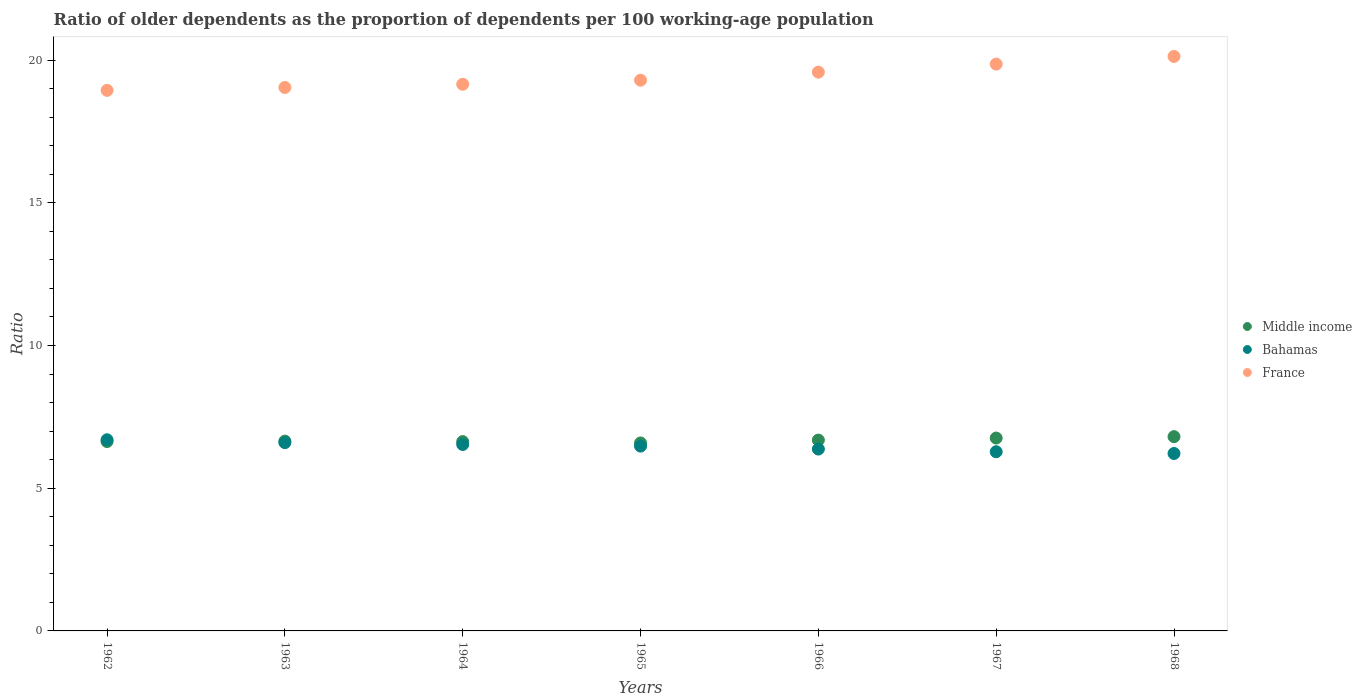What is the age dependency ratio(old) in France in 1967?
Provide a succinct answer. 19.86. Across all years, what is the maximum age dependency ratio(old) in France?
Offer a terse response. 20.13. Across all years, what is the minimum age dependency ratio(old) in France?
Provide a succinct answer. 18.94. In which year was the age dependency ratio(old) in Middle income maximum?
Ensure brevity in your answer.  1968. In which year was the age dependency ratio(old) in Bahamas minimum?
Your response must be concise. 1968. What is the total age dependency ratio(old) in Middle income in the graph?
Offer a terse response. 46.76. What is the difference between the age dependency ratio(old) in Bahamas in 1964 and that in 1966?
Provide a short and direct response. 0.16. What is the difference between the age dependency ratio(old) in Bahamas in 1966 and the age dependency ratio(old) in France in 1968?
Your response must be concise. -13.76. What is the average age dependency ratio(old) in Middle income per year?
Offer a very short reply. 6.68. In the year 1966, what is the difference between the age dependency ratio(old) in France and age dependency ratio(old) in Middle income?
Keep it short and to the point. 12.89. What is the ratio of the age dependency ratio(old) in Bahamas in 1964 to that in 1967?
Keep it short and to the point. 1.04. Is the age dependency ratio(old) in Middle income in 1962 less than that in 1963?
Provide a short and direct response. Yes. What is the difference between the highest and the second highest age dependency ratio(old) in Bahamas?
Your answer should be very brief. 0.1. What is the difference between the highest and the lowest age dependency ratio(old) in France?
Your answer should be very brief. 1.19. Does the age dependency ratio(old) in Middle income monotonically increase over the years?
Ensure brevity in your answer.  No. Is the age dependency ratio(old) in Bahamas strictly greater than the age dependency ratio(old) in France over the years?
Your answer should be compact. No. What is the difference between two consecutive major ticks on the Y-axis?
Your answer should be compact. 5. Does the graph contain any zero values?
Your answer should be compact. No. Does the graph contain grids?
Provide a succinct answer. No. How many legend labels are there?
Offer a terse response. 3. How are the legend labels stacked?
Ensure brevity in your answer.  Vertical. What is the title of the graph?
Provide a short and direct response. Ratio of older dependents as the proportion of dependents per 100 working-age population. What is the label or title of the Y-axis?
Your answer should be very brief. Ratio. What is the Ratio in Middle income in 1962?
Keep it short and to the point. 6.64. What is the Ratio in Bahamas in 1962?
Your answer should be very brief. 6.7. What is the Ratio in France in 1962?
Your answer should be compact. 18.94. What is the Ratio in Middle income in 1963?
Your answer should be very brief. 6.65. What is the Ratio of Bahamas in 1963?
Ensure brevity in your answer.  6.6. What is the Ratio of France in 1963?
Offer a very short reply. 19.04. What is the Ratio in Middle income in 1964?
Your answer should be compact. 6.63. What is the Ratio in Bahamas in 1964?
Offer a very short reply. 6.53. What is the Ratio in France in 1964?
Provide a short and direct response. 19.15. What is the Ratio of Middle income in 1965?
Offer a terse response. 6.59. What is the Ratio in Bahamas in 1965?
Your response must be concise. 6.48. What is the Ratio of France in 1965?
Your answer should be very brief. 19.3. What is the Ratio in Middle income in 1966?
Provide a succinct answer. 6.69. What is the Ratio of Bahamas in 1966?
Offer a terse response. 6.37. What is the Ratio of France in 1966?
Make the answer very short. 19.58. What is the Ratio of Middle income in 1967?
Offer a very short reply. 6.76. What is the Ratio of Bahamas in 1967?
Your answer should be compact. 6.28. What is the Ratio of France in 1967?
Your answer should be compact. 19.86. What is the Ratio in Middle income in 1968?
Your response must be concise. 6.81. What is the Ratio in Bahamas in 1968?
Your response must be concise. 6.22. What is the Ratio of France in 1968?
Provide a succinct answer. 20.13. Across all years, what is the maximum Ratio in Middle income?
Make the answer very short. 6.81. Across all years, what is the maximum Ratio of Bahamas?
Provide a short and direct response. 6.7. Across all years, what is the maximum Ratio in France?
Ensure brevity in your answer.  20.13. Across all years, what is the minimum Ratio in Middle income?
Ensure brevity in your answer.  6.59. Across all years, what is the minimum Ratio of Bahamas?
Provide a succinct answer. 6.22. Across all years, what is the minimum Ratio of France?
Give a very brief answer. 18.94. What is the total Ratio in Middle income in the graph?
Give a very brief answer. 46.76. What is the total Ratio of Bahamas in the graph?
Make the answer very short. 45.17. What is the total Ratio of France in the graph?
Offer a terse response. 136. What is the difference between the Ratio in Middle income in 1962 and that in 1963?
Make the answer very short. -0.02. What is the difference between the Ratio in Bahamas in 1962 and that in 1963?
Offer a very short reply. 0.1. What is the difference between the Ratio in France in 1962 and that in 1963?
Make the answer very short. -0.1. What is the difference between the Ratio in Middle income in 1962 and that in 1964?
Give a very brief answer. 0. What is the difference between the Ratio of Bahamas in 1962 and that in 1964?
Provide a short and direct response. 0.16. What is the difference between the Ratio of France in 1962 and that in 1964?
Keep it short and to the point. -0.21. What is the difference between the Ratio in Middle income in 1962 and that in 1965?
Keep it short and to the point. 0.05. What is the difference between the Ratio in Bahamas in 1962 and that in 1965?
Offer a terse response. 0.22. What is the difference between the Ratio in France in 1962 and that in 1965?
Your answer should be very brief. -0.36. What is the difference between the Ratio in Middle income in 1962 and that in 1966?
Give a very brief answer. -0.05. What is the difference between the Ratio of Bahamas in 1962 and that in 1966?
Provide a short and direct response. 0.33. What is the difference between the Ratio of France in 1962 and that in 1966?
Your response must be concise. -0.64. What is the difference between the Ratio of Middle income in 1962 and that in 1967?
Make the answer very short. -0.12. What is the difference between the Ratio in Bahamas in 1962 and that in 1967?
Make the answer very short. 0.42. What is the difference between the Ratio of France in 1962 and that in 1967?
Keep it short and to the point. -0.92. What is the difference between the Ratio of Middle income in 1962 and that in 1968?
Make the answer very short. -0.17. What is the difference between the Ratio in Bahamas in 1962 and that in 1968?
Your answer should be very brief. 0.48. What is the difference between the Ratio of France in 1962 and that in 1968?
Keep it short and to the point. -1.19. What is the difference between the Ratio in Middle income in 1963 and that in 1964?
Ensure brevity in your answer.  0.02. What is the difference between the Ratio in Bahamas in 1963 and that in 1964?
Provide a succinct answer. 0.07. What is the difference between the Ratio in France in 1963 and that in 1964?
Provide a succinct answer. -0.11. What is the difference between the Ratio of Middle income in 1963 and that in 1965?
Keep it short and to the point. 0.07. What is the difference between the Ratio of Bahamas in 1963 and that in 1965?
Keep it short and to the point. 0.12. What is the difference between the Ratio in France in 1963 and that in 1965?
Your answer should be very brief. -0.25. What is the difference between the Ratio of Middle income in 1963 and that in 1966?
Ensure brevity in your answer.  -0.04. What is the difference between the Ratio of Bahamas in 1963 and that in 1966?
Provide a succinct answer. 0.23. What is the difference between the Ratio in France in 1963 and that in 1966?
Give a very brief answer. -0.54. What is the difference between the Ratio in Middle income in 1963 and that in 1967?
Make the answer very short. -0.11. What is the difference between the Ratio in Bahamas in 1963 and that in 1967?
Your response must be concise. 0.32. What is the difference between the Ratio in France in 1963 and that in 1967?
Provide a short and direct response. -0.82. What is the difference between the Ratio of Middle income in 1963 and that in 1968?
Offer a very short reply. -0.16. What is the difference between the Ratio of Bahamas in 1963 and that in 1968?
Make the answer very short. 0.38. What is the difference between the Ratio of France in 1963 and that in 1968?
Offer a terse response. -1.09. What is the difference between the Ratio of Middle income in 1964 and that in 1965?
Provide a succinct answer. 0.05. What is the difference between the Ratio in Bahamas in 1964 and that in 1965?
Ensure brevity in your answer.  0.06. What is the difference between the Ratio in France in 1964 and that in 1965?
Give a very brief answer. -0.14. What is the difference between the Ratio in Middle income in 1964 and that in 1966?
Ensure brevity in your answer.  -0.05. What is the difference between the Ratio in Bahamas in 1964 and that in 1966?
Ensure brevity in your answer.  0.16. What is the difference between the Ratio in France in 1964 and that in 1966?
Give a very brief answer. -0.43. What is the difference between the Ratio of Middle income in 1964 and that in 1967?
Ensure brevity in your answer.  -0.12. What is the difference between the Ratio of Bahamas in 1964 and that in 1967?
Offer a terse response. 0.25. What is the difference between the Ratio in France in 1964 and that in 1967?
Your response must be concise. -0.71. What is the difference between the Ratio in Middle income in 1964 and that in 1968?
Keep it short and to the point. -0.17. What is the difference between the Ratio of Bahamas in 1964 and that in 1968?
Your response must be concise. 0.32. What is the difference between the Ratio of France in 1964 and that in 1968?
Ensure brevity in your answer.  -0.98. What is the difference between the Ratio in Middle income in 1965 and that in 1966?
Ensure brevity in your answer.  -0.1. What is the difference between the Ratio in Bahamas in 1965 and that in 1966?
Provide a short and direct response. 0.1. What is the difference between the Ratio in France in 1965 and that in 1966?
Make the answer very short. -0.28. What is the difference between the Ratio in Middle income in 1965 and that in 1967?
Your answer should be very brief. -0.17. What is the difference between the Ratio of Bahamas in 1965 and that in 1967?
Provide a short and direct response. 0.2. What is the difference between the Ratio in France in 1965 and that in 1967?
Make the answer very short. -0.56. What is the difference between the Ratio in Middle income in 1965 and that in 1968?
Give a very brief answer. -0.22. What is the difference between the Ratio in Bahamas in 1965 and that in 1968?
Keep it short and to the point. 0.26. What is the difference between the Ratio of France in 1965 and that in 1968?
Your response must be concise. -0.83. What is the difference between the Ratio of Middle income in 1966 and that in 1967?
Your answer should be very brief. -0.07. What is the difference between the Ratio in Bahamas in 1966 and that in 1967?
Your answer should be compact. 0.09. What is the difference between the Ratio of France in 1966 and that in 1967?
Make the answer very short. -0.28. What is the difference between the Ratio in Middle income in 1966 and that in 1968?
Provide a short and direct response. -0.12. What is the difference between the Ratio of Bahamas in 1966 and that in 1968?
Provide a succinct answer. 0.15. What is the difference between the Ratio of France in 1966 and that in 1968?
Give a very brief answer. -0.55. What is the difference between the Ratio of Middle income in 1967 and that in 1968?
Make the answer very short. -0.05. What is the difference between the Ratio of Bahamas in 1967 and that in 1968?
Offer a terse response. 0.06. What is the difference between the Ratio of France in 1967 and that in 1968?
Your response must be concise. -0.27. What is the difference between the Ratio of Middle income in 1962 and the Ratio of Bahamas in 1963?
Make the answer very short. 0.04. What is the difference between the Ratio of Middle income in 1962 and the Ratio of France in 1963?
Provide a succinct answer. -12.41. What is the difference between the Ratio of Bahamas in 1962 and the Ratio of France in 1963?
Ensure brevity in your answer.  -12.34. What is the difference between the Ratio of Middle income in 1962 and the Ratio of Bahamas in 1964?
Your response must be concise. 0.1. What is the difference between the Ratio in Middle income in 1962 and the Ratio in France in 1964?
Provide a succinct answer. -12.52. What is the difference between the Ratio in Bahamas in 1962 and the Ratio in France in 1964?
Give a very brief answer. -12.46. What is the difference between the Ratio in Middle income in 1962 and the Ratio in Bahamas in 1965?
Give a very brief answer. 0.16. What is the difference between the Ratio of Middle income in 1962 and the Ratio of France in 1965?
Make the answer very short. -12.66. What is the difference between the Ratio in Bahamas in 1962 and the Ratio in France in 1965?
Give a very brief answer. -12.6. What is the difference between the Ratio in Middle income in 1962 and the Ratio in Bahamas in 1966?
Keep it short and to the point. 0.26. What is the difference between the Ratio in Middle income in 1962 and the Ratio in France in 1966?
Your answer should be very brief. -12.94. What is the difference between the Ratio in Bahamas in 1962 and the Ratio in France in 1966?
Make the answer very short. -12.88. What is the difference between the Ratio of Middle income in 1962 and the Ratio of Bahamas in 1967?
Give a very brief answer. 0.36. What is the difference between the Ratio of Middle income in 1962 and the Ratio of France in 1967?
Make the answer very short. -13.22. What is the difference between the Ratio of Bahamas in 1962 and the Ratio of France in 1967?
Keep it short and to the point. -13.16. What is the difference between the Ratio of Middle income in 1962 and the Ratio of Bahamas in 1968?
Ensure brevity in your answer.  0.42. What is the difference between the Ratio of Middle income in 1962 and the Ratio of France in 1968?
Provide a succinct answer. -13.49. What is the difference between the Ratio of Bahamas in 1962 and the Ratio of France in 1968?
Offer a terse response. -13.43. What is the difference between the Ratio of Middle income in 1963 and the Ratio of Bahamas in 1964?
Provide a short and direct response. 0.12. What is the difference between the Ratio in Middle income in 1963 and the Ratio in France in 1964?
Your answer should be compact. -12.5. What is the difference between the Ratio in Bahamas in 1963 and the Ratio in France in 1964?
Your answer should be very brief. -12.56. What is the difference between the Ratio of Middle income in 1963 and the Ratio of Bahamas in 1965?
Your answer should be very brief. 0.18. What is the difference between the Ratio in Middle income in 1963 and the Ratio in France in 1965?
Your answer should be compact. -12.64. What is the difference between the Ratio of Bahamas in 1963 and the Ratio of France in 1965?
Your answer should be very brief. -12.7. What is the difference between the Ratio in Middle income in 1963 and the Ratio in Bahamas in 1966?
Ensure brevity in your answer.  0.28. What is the difference between the Ratio in Middle income in 1963 and the Ratio in France in 1966?
Keep it short and to the point. -12.93. What is the difference between the Ratio of Bahamas in 1963 and the Ratio of France in 1966?
Give a very brief answer. -12.98. What is the difference between the Ratio in Middle income in 1963 and the Ratio in Bahamas in 1967?
Keep it short and to the point. 0.37. What is the difference between the Ratio of Middle income in 1963 and the Ratio of France in 1967?
Your answer should be very brief. -13.21. What is the difference between the Ratio of Bahamas in 1963 and the Ratio of France in 1967?
Your response must be concise. -13.26. What is the difference between the Ratio of Middle income in 1963 and the Ratio of Bahamas in 1968?
Provide a succinct answer. 0.43. What is the difference between the Ratio of Middle income in 1963 and the Ratio of France in 1968?
Ensure brevity in your answer.  -13.48. What is the difference between the Ratio of Bahamas in 1963 and the Ratio of France in 1968?
Give a very brief answer. -13.53. What is the difference between the Ratio of Middle income in 1964 and the Ratio of Bahamas in 1965?
Provide a succinct answer. 0.16. What is the difference between the Ratio of Middle income in 1964 and the Ratio of France in 1965?
Keep it short and to the point. -12.66. What is the difference between the Ratio in Bahamas in 1964 and the Ratio in France in 1965?
Provide a short and direct response. -12.76. What is the difference between the Ratio of Middle income in 1964 and the Ratio of Bahamas in 1966?
Your answer should be very brief. 0.26. What is the difference between the Ratio of Middle income in 1964 and the Ratio of France in 1966?
Your answer should be very brief. -12.94. What is the difference between the Ratio of Bahamas in 1964 and the Ratio of France in 1966?
Make the answer very short. -13.05. What is the difference between the Ratio of Middle income in 1964 and the Ratio of Bahamas in 1967?
Keep it short and to the point. 0.36. What is the difference between the Ratio in Middle income in 1964 and the Ratio in France in 1967?
Your response must be concise. -13.23. What is the difference between the Ratio in Bahamas in 1964 and the Ratio in France in 1967?
Your response must be concise. -13.33. What is the difference between the Ratio in Middle income in 1964 and the Ratio in Bahamas in 1968?
Offer a terse response. 0.42. What is the difference between the Ratio of Middle income in 1964 and the Ratio of France in 1968?
Ensure brevity in your answer.  -13.49. What is the difference between the Ratio of Bahamas in 1964 and the Ratio of France in 1968?
Your answer should be compact. -13.6. What is the difference between the Ratio in Middle income in 1965 and the Ratio in Bahamas in 1966?
Offer a terse response. 0.21. What is the difference between the Ratio in Middle income in 1965 and the Ratio in France in 1966?
Offer a terse response. -12.99. What is the difference between the Ratio of Bahamas in 1965 and the Ratio of France in 1966?
Offer a very short reply. -13.1. What is the difference between the Ratio in Middle income in 1965 and the Ratio in Bahamas in 1967?
Your answer should be very brief. 0.31. What is the difference between the Ratio of Middle income in 1965 and the Ratio of France in 1967?
Ensure brevity in your answer.  -13.27. What is the difference between the Ratio in Bahamas in 1965 and the Ratio in France in 1967?
Your response must be concise. -13.38. What is the difference between the Ratio of Middle income in 1965 and the Ratio of Bahamas in 1968?
Your response must be concise. 0.37. What is the difference between the Ratio of Middle income in 1965 and the Ratio of France in 1968?
Offer a very short reply. -13.54. What is the difference between the Ratio in Bahamas in 1965 and the Ratio in France in 1968?
Offer a terse response. -13.65. What is the difference between the Ratio in Middle income in 1966 and the Ratio in Bahamas in 1967?
Give a very brief answer. 0.41. What is the difference between the Ratio in Middle income in 1966 and the Ratio in France in 1967?
Your answer should be compact. -13.17. What is the difference between the Ratio in Bahamas in 1966 and the Ratio in France in 1967?
Provide a succinct answer. -13.49. What is the difference between the Ratio in Middle income in 1966 and the Ratio in Bahamas in 1968?
Provide a short and direct response. 0.47. What is the difference between the Ratio of Middle income in 1966 and the Ratio of France in 1968?
Your response must be concise. -13.44. What is the difference between the Ratio of Bahamas in 1966 and the Ratio of France in 1968?
Ensure brevity in your answer.  -13.76. What is the difference between the Ratio in Middle income in 1967 and the Ratio in Bahamas in 1968?
Your answer should be very brief. 0.54. What is the difference between the Ratio in Middle income in 1967 and the Ratio in France in 1968?
Provide a short and direct response. -13.37. What is the difference between the Ratio in Bahamas in 1967 and the Ratio in France in 1968?
Offer a terse response. -13.85. What is the average Ratio in Middle income per year?
Your answer should be compact. 6.68. What is the average Ratio of Bahamas per year?
Give a very brief answer. 6.45. What is the average Ratio in France per year?
Ensure brevity in your answer.  19.43. In the year 1962, what is the difference between the Ratio of Middle income and Ratio of Bahamas?
Offer a terse response. -0.06. In the year 1962, what is the difference between the Ratio in Middle income and Ratio in France?
Your answer should be compact. -12.3. In the year 1962, what is the difference between the Ratio in Bahamas and Ratio in France?
Offer a terse response. -12.24. In the year 1963, what is the difference between the Ratio of Middle income and Ratio of Bahamas?
Offer a terse response. 0.05. In the year 1963, what is the difference between the Ratio in Middle income and Ratio in France?
Ensure brevity in your answer.  -12.39. In the year 1963, what is the difference between the Ratio in Bahamas and Ratio in France?
Your answer should be very brief. -12.44. In the year 1964, what is the difference between the Ratio of Middle income and Ratio of Bahamas?
Your response must be concise. 0.1. In the year 1964, what is the difference between the Ratio of Middle income and Ratio of France?
Your answer should be compact. -12.52. In the year 1964, what is the difference between the Ratio of Bahamas and Ratio of France?
Give a very brief answer. -12.62. In the year 1965, what is the difference between the Ratio in Middle income and Ratio in Bahamas?
Your response must be concise. 0.11. In the year 1965, what is the difference between the Ratio in Middle income and Ratio in France?
Your response must be concise. -12.71. In the year 1965, what is the difference between the Ratio of Bahamas and Ratio of France?
Offer a very short reply. -12.82. In the year 1966, what is the difference between the Ratio of Middle income and Ratio of Bahamas?
Your response must be concise. 0.31. In the year 1966, what is the difference between the Ratio of Middle income and Ratio of France?
Provide a succinct answer. -12.89. In the year 1966, what is the difference between the Ratio in Bahamas and Ratio in France?
Make the answer very short. -13.21. In the year 1967, what is the difference between the Ratio of Middle income and Ratio of Bahamas?
Offer a terse response. 0.48. In the year 1967, what is the difference between the Ratio in Middle income and Ratio in France?
Provide a succinct answer. -13.1. In the year 1967, what is the difference between the Ratio in Bahamas and Ratio in France?
Make the answer very short. -13.58. In the year 1968, what is the difference between the Ratio in Middle income and Ratio in Bahamas?
Keep it short and to the point. 0.59. In the year 1968, what is the difference between the Ratio in Middle income and Ratio in France?
Offer a terse response. -13.32. In the year 1968, what is the difference between the Ratio of Bahamas and Ratio of France?
Offer a terse response. -13.91. What is the ratio of the Ratio in Bahamas in 1962 to that in 1963?
Provide a short and direct response. 1.02. What is the ratio of the Ratio of France in 1962 to that in 1963?
Offer a terse response. 0.99. What is the ratio of the Ratio in Middle income in 1962 to that in 1964?
Offer a very short reply. 1. What is the ratio of the Ratio in Bahamas in 1962 to that in 1964?
Keep it short and to the point. 1.03. What is the ratio of the Ratio of France in 1962 to that in 1964?
Your answer should be compact. 0.99. What is the ratio of the Ratio in Middle income in 1962 to that in 1965?
Offer a very short reply. 1.01. What is the ratio of the Ratio in Bahamas in 1962 to that in 1965?
Your response must be concise. 1.03. What is the ratio of the Ratio in France in 1962 to that in 1965?
Your answer should be compact. 0.98. What is the ratio of the Ratio in Middle income in 1962 to that in 1966?
Your answer should be compact. 0.99. What is the ratio of the Ratio of Bahamas in 1962 to that in 1966?
Keep it short and to the point. 1.05. What is the ratio of the Ratio in France in 1962 to that in 1966?
Offer a very short reply. 0.97. What is the ratio of the Ratio of Middle income in 1962 to that in 1967?
Ensure brevity in your answer.  0.98. What is the ratio of the Ratio of Bahamas in 1962 to that in 1967?
Offer a terse response. 1.07. What is the ratio of the Ratio in France in 1962 to that in 1967?
Offer a terse response. 0.95. What is the ratio of the Ratio of Middle income in 1962 to that in 1968?
Ensure brevity in your answer.  0.97. What is the ratio of the Ratio of Bahamas in 1962 to that in 1968?
Provide a short and direct response. 1.08. What is the ratio of the Ratio in France in 1962 to that in 1968?
Your answer should be very brief. 0.94. What is the ratio of the Ratio in Middle income in 1963 to that in 1965?
Ensure brevity in your answer.  1.01. What is the ratio of the Ratio in Bahamas in 1963 to that in 1965?
Provide a short and direct response. 1.02. What is the ratio of the Ratio of France in 1963 to that in 1965?
Offer a very short reply. 0.99. What is the ratio of the Ratio of Bahamas in 1963 to that in 1966?
Offer a very short reply. 1.04. What is the ratio of the Ratio in France in 1963 to that in 1966?
Your answer should be very brief. 0.97. What is the ratio of the Ratio in Middle income in 1963 to that in 1967?
Your response must be concise. 0.98. What is the ratio of the Ratio of Bahamas in 1963 to that in 1967?
Keep it short and to the point. 1.05. What is the ratio of the Ratio in France in 1963 to that in 1967?
Your answer should be very brief. 0.96. What is the ratio of the Ratio in Middle income in 1963 to that in 1968?
Provide a succinct answer. 0.98. What is the ratio of the Ratio in Bahamas in 1963 to that in 1968?
Your answer should be compact. 1.06. What is the ratio of the Ratio of France in 1963 to that in 1968?
Your response must be concise. 0.95. What is the ratio of the Ratio in Middle income in 1964 to that in 1965?
Keep it short and to the point. 1.01. What is the ratio of the Ratio of Bahamas in 1964 to that in 1965?
Offer a terse response. 1.01. What is the ratio of the Ratio of Bahamas in 1964 to that in 1966?
Your answer should be compact. 1.03. What is the ratio of the Ratio of France in 1964 to that in 1966?
Keep it short and to the point. 0.98. What is the ratio of the Ratio of Middle income in 1964 to that in 1967?
Ensure brevity in your answer.  0.98. What is the ratio of the Ratio of Bahamas in 1964 to that in 1967?
Offer a very short reply. 1.04. What is the ratio of the Ratio of France in 1964 to that in 1967?
Provide a succinct answer. 0.96. What is the ratio of the Ratio of Middle income in 1964 to that in 1968?
Provide a short and direct response. 0.97. What is the ratio of the Ratio of Bahamas in 1964 to that in 1968?
Keep it short and to the point. 1.05. What is the ratio of the Ratio of France in 1964 to that in 1968?
Make the answer very short. 0.95. What is the ratio of the Ratio in Middle income in 1965 to that in 1966?
Offer a very short reply. 0.98. What is the ratio of the Ratio of Bahamas in 1965 to that in 1966?
Provide a succinct answer. 1.02. What is the ratio of the Ratio of France in 1965 to that in 1966?
Provide a succinct answer. 0.99. What is the ratio of the Ratio of Middle income in 1965 to that in 1967?
Keep it short and to the point. 0.97. What is the ratio of the Ratio in Bahamas in 1965 to that in 1967?
Offer a terse response. 1.03. What is the ratio of the Ratio in France in 1965 to that in 1967?
Offer a very short reply. 0.97. What is the ratio of the Ratio in Middle income in 1965 to that in 1968?
Offer a terse response. 0.97. What is the ratio of the Ratio in Bahamas in 1965 to that in 1968?
Provide a short and direct response. 1.04. What is the ratio of the Ratio of France in 1965 to that in 1968?
Provide a succinct answer. 0.96. What is the ratio of the Ratio of Middle income in 1966 to that in 1967?
Keep it short and to the point. 0.99. What is the ratio of the Ratio in Bahamas in 1966 to that in 1967?
Provide a succinct answer. 1.01. What is the ratio of the Ratio of France in 1966 to that in 1967?
Your answer should be very brief. 0.99. What is the ratio of the Ratio of Middle income in 1966 to that in 1968?
Offer a terse response. 0.98. What is the ratio of the Ratio of Bahamas in 1966 to that in 1968?
Keep it short and to the point. 1.02. What is the ratio of the Ratio in France in 1966 to that in 1968?
Your answer should be very brief. 0.97. What is the ratio of the Ratio of Middle income in 1967 to that in 1968?
Your answer should be very brief. 0.99. What is the ratio of the Ratio in Bahamas in 1967 to that in 1968?
Make the answer very short. 1.01. What is the ratio of the Ratio in France in 1967 to that in 1968?
Provide a short and direct response. 0.99. What is the difference between the highest and the second highest Ratio of Middle income?
Offer a terse response. 0.05. What is the difference between the highest and the second highest Ratio of Bahamas?
Provide a succinct answer. 0.1. What is the difference between the highest and the second highest Ratio of France?
Your response must be concise. 0.27. What is the difference between the highest and the lowest Ratio of Middle income?
Keep it short and to the point. 0.22. What is the difference between the highest and the lowest Ratio of Bahamas?
Offer a very short reply. 0.48. What is the difference between the highest and the lowest Ratio in France?
Offer a very short reply. 1.19. 